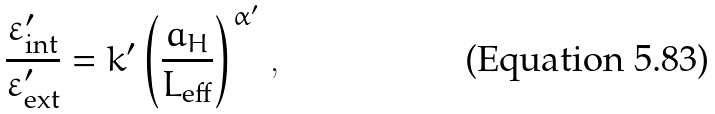Convert formula to latex. <formula><loc_0><loc_0><loc_500><loc_500>\frac { \varepsilon ^ { \prime } _ { \text {int} } } { \varepsilon ^ { \prime } _ { \text {ext} } } = k ^ { \prime } \left ( \frac { a _ { H } } { L _ { \text {eff} } } \right ) ^ { \alpha ^ { \prime } } \, ,</formula> 